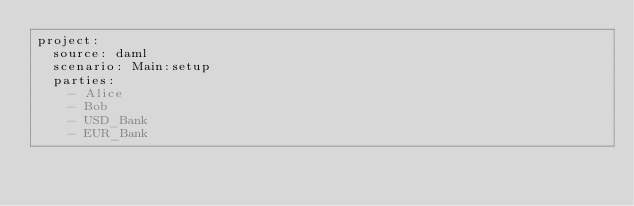Convert code to text. <code><loc_0><loc_0><loc_500><loc_500><_YAML_>project:
  source: daml
  scenario: Main:setup
  parties:
    - Alice
    - Bob
    - USD_Bank
    - EUR_Bank
</code> 